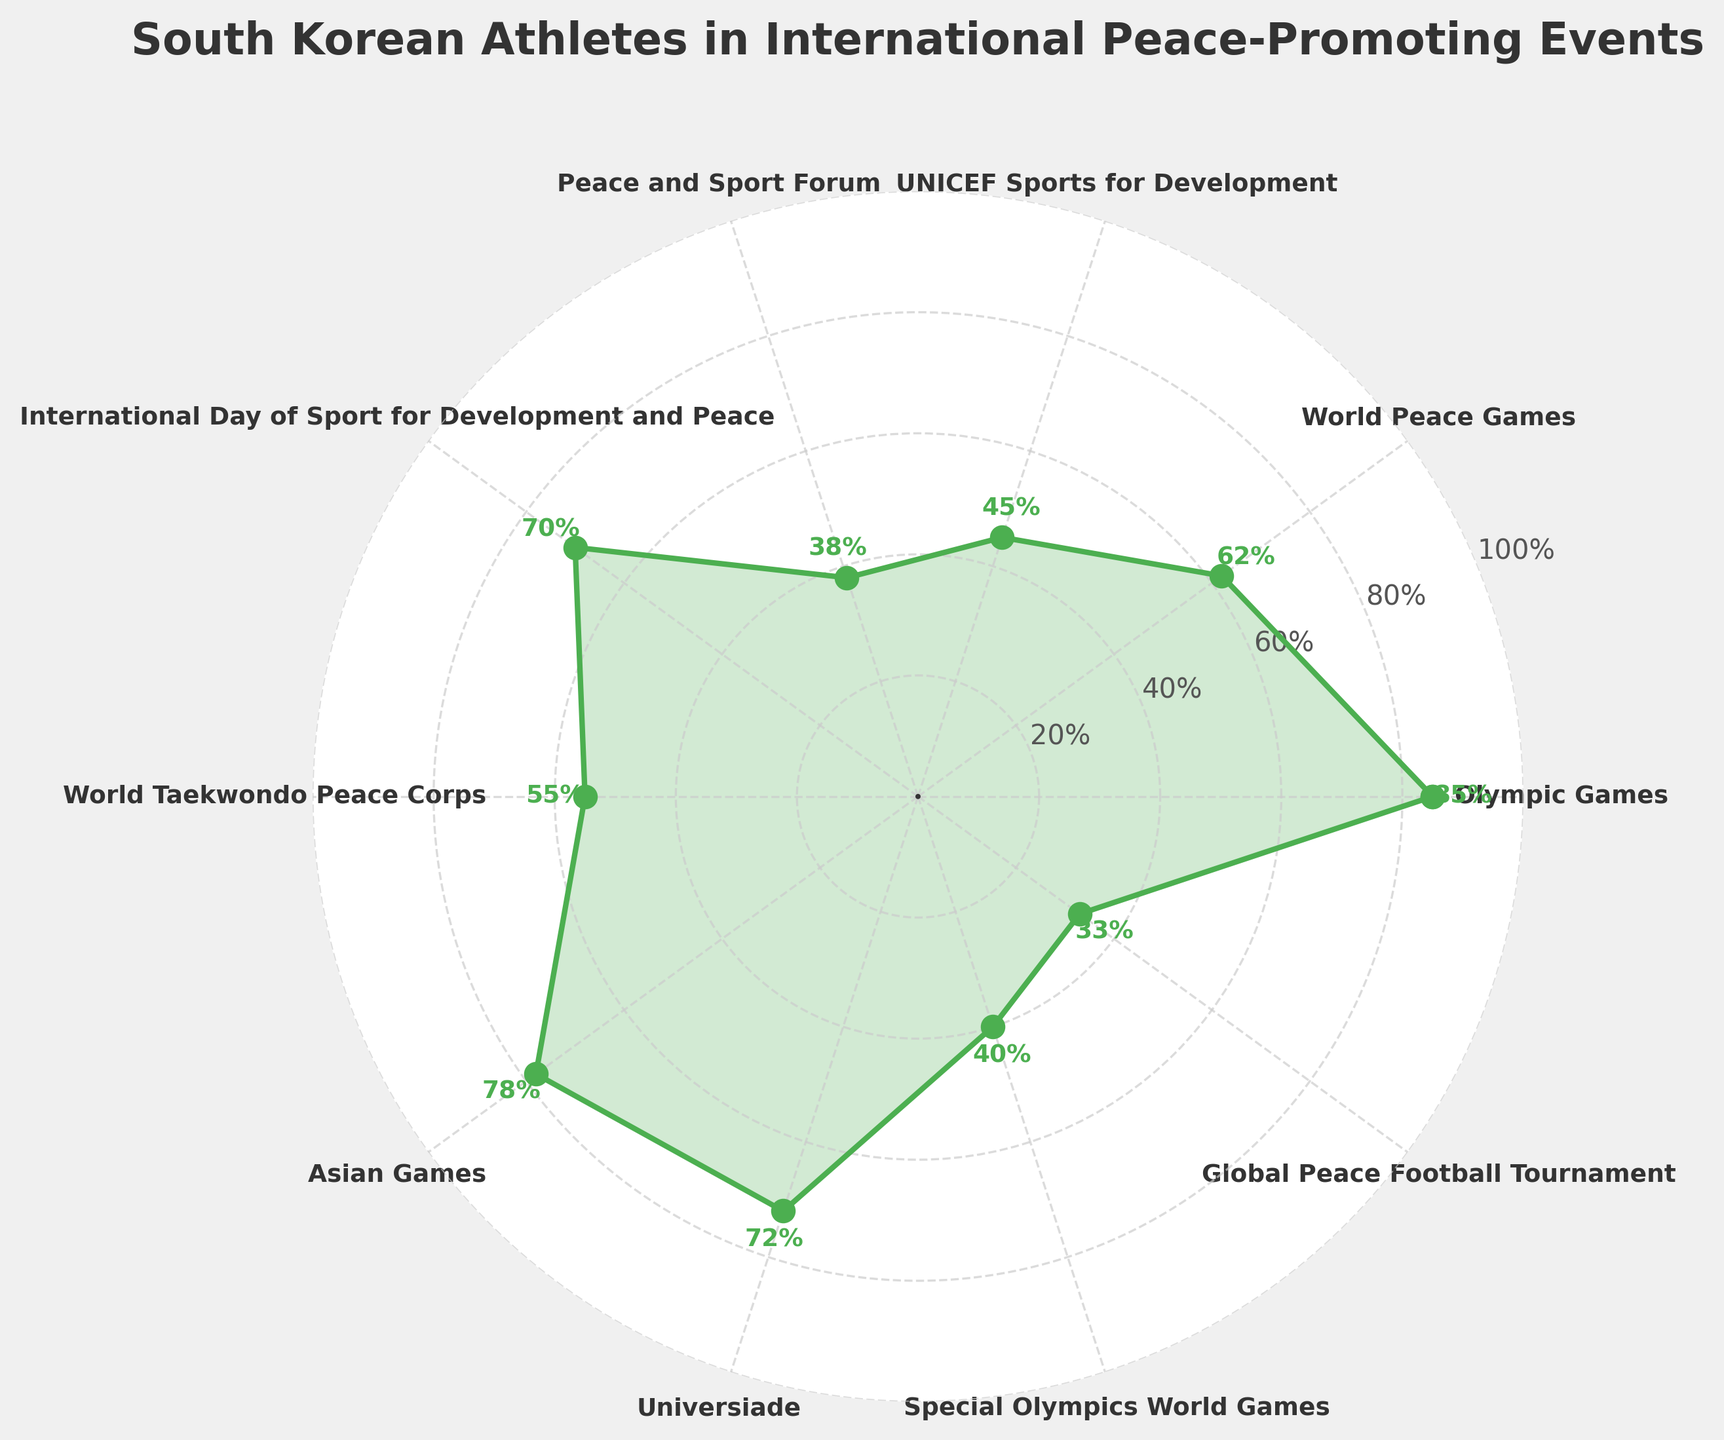What's the title of the figure? The title of the figure is displayed at the top and reads "South Korean Athletes in International Peace-Promoting Events".
Answer: South Korean Athletes in International Peace-Promoting Events How many events are presented in the figure? By counting the number of labels or markers on the chart, it can be observed that there are ten events.
Answer: 10 Which event has the highest percentage of South Korean athletes participating? By observing the highest point on the plot and checking the event label, it can be seen that the Olympic Games have the highest percentage of athletes participating (85%).
Answer: Olympic Games Which event has the lowest percentage of South Korean athletes participating? The lowest point on the chart represents the event with the lowest percentage of participation, which is the Global Peace Football Tournament at 33%.
Answer: Global Peace Football Tournament What is the average percentage of South Korean athletes participating across all events? Add all the percentages: 85 + 62 + 45 + 38 + 70 + 55 + 78 + 72 + 40 + 33 = 578. Divide by the number of events (10). So, the average is 578/10 = 57.8%.
Answer: 57.8% How many events have participation rates above 50%? The events with participation rates above 50% are Olympic Games (85%), World Peace Games (62%), International Day of Sport for Development and Peace (70%), Asian Games (78%), Universiade (72%), World Taekwondo Peace Corps (55%). There are 6 such events.
Answer: 6 Are there more events with participation percentages below 50% or above 50%? Count the number of events above 50% (6) and below 50% (4). There are more events above 50%.
Answer: Above 50% How does the participation in the Peace and Sport Forum compare to the UNICEF Sports for Development? The bar for the Peace and Sport Forum indicates a participation of 38%, while UNICEF Sports for Development has 45%. UNICEF Sports for Development has a higher participation percentage.
Answer: UNICEF Sports for Development What is the total percentage sum of South Korean athletes participating in the Special Olympics World Games and the Global Peace Football Tournament? Add the percentages for Special Olympics World Games (40%) and Global Peace Football Tournament (33%): 40 + 33 = 73.
Answer: 73% Which event has the closest participation percentage to 70%? By observing the plot, International Day of Sport for Development and Peace has a participation of 70%, matching exactly. The next closest is Universiade at 72%.
Answer: International Day of Sport for Development and Peace 